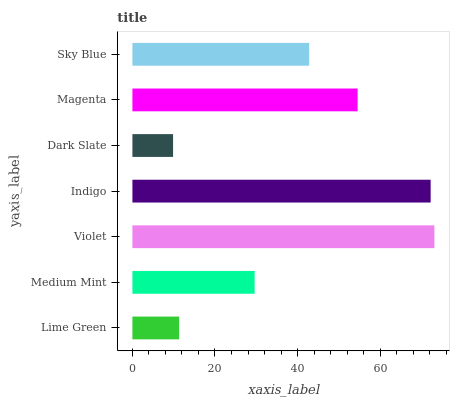Is Dark Slate the minimum?
Answer yes or no. Yes. Is Violet the maximum?
Answer yes or no. Yes. Is Medium Mint the minimum?
Answer yes or no. No. Is Medium Mint the maximum?
Answer yes or no. No. Is Medium Mint greater than Lime Green?
Answer yes or no. Yes. Is Lime Green less than Medium Mint?
Answer yes or no. Yes. Is Lime Green greater than Medium Mint?
Answer yes or no. No. Is Medium Mint less than Lime Green?
Answer yes or no. No. Is Sky Blue the high median?
Answer yes or no. Yes. Is Sky Blue the low median?
Answer yes or no. Yes. Is Lime Green the high median?
Answer yes or no. No. Is Dark Slate the low median?
Answer yes or no. No. 